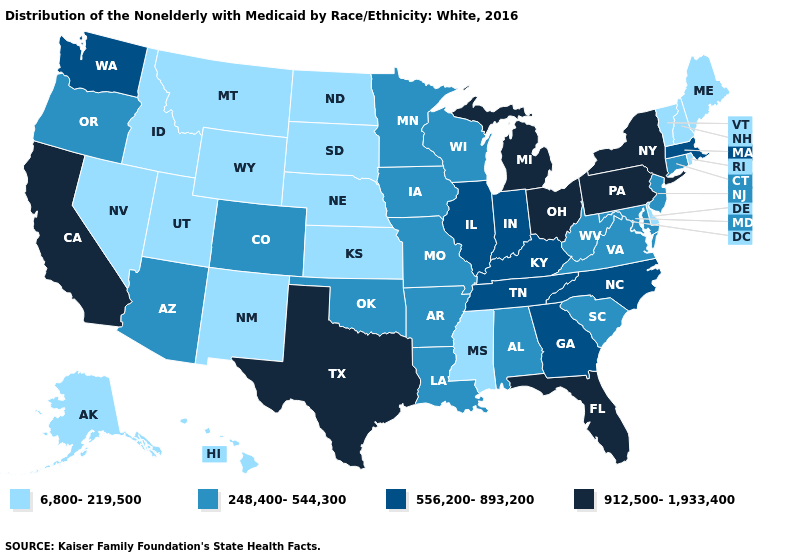Among the states that border Texas , which have the highest value?
Quick response, please. Arkansas, Louisiana, Oklahoma. What is the lowest value in the USA?
Keep it brief. 6,800-219,500. Does Ohio have the lowest value in the USA?
Concise answer only. No. What is the value of New Hampshire?
Short answer required. 6,800-219,500. Does Idaho have the highest value in the West?
Keep it brief. No. Name the states that have a value in the range 912,500-1,933,400?
Keep it brief. California, Florida, Michigan, New York, Ohio, Pennsylvania, Texas. Name the states that have a value in the range 912,500-1,933,400?
Short answer required. California, Florida, Michigan, New York, Ohio, Pennsylvania, Texas. Among the states that border Mississippi , does Tennessee have the lowest value?
Quick response, please. No. What is the lowest value in the South?
Be succinct. 6,800-219,500. Does Michigan have the highest value in the USA?
Concise answer only. Yes. What is the value of Georgia?
Be succinct. 556,200-893,200. Name the states that have a value in the range 556,200-893,200?
Keep it brief. Georgia, Illinois, Indiana, Kentucky, Massachusetts, North Carolina, Tennessee, Washington. Does California have the highest value in the West?
Quick response, please. Yes. What is the value of Delaware?
Write a very short answer. 6,800-219,500. 